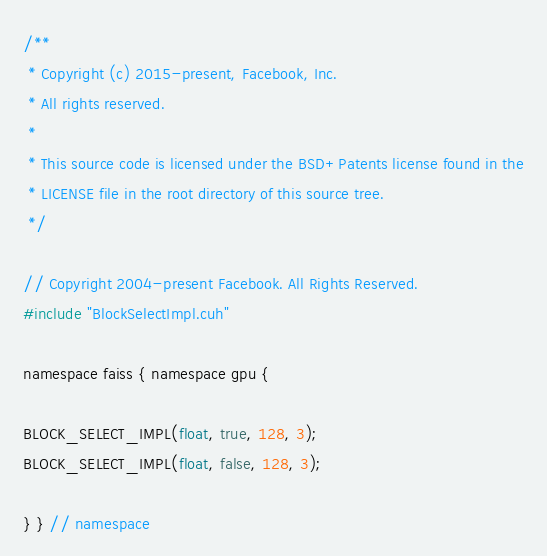Convert code to text. <code><loc_0><loc_0><loc_500><loc_500><_Cuda_>/**
 * Copyright (c) 2015-present, Facebook, Inc.
 * All rights reserved.
 *
 * This source code is licensed under the BSD+Patents license found in the
 * LICENSE file in the root directory of this source tree.
 */

// Copyright 2004-present Facebook. All Rights Reserved.
#include "BlockSelectImpl.cuh"

namespace faiss { namespace gpu {

BLOCK_SELECT_IMPL(float, true, 128, 3);
BLOCK_SELECT_IMPL(float, false, 128, 3);

} } // namespace
</code> 